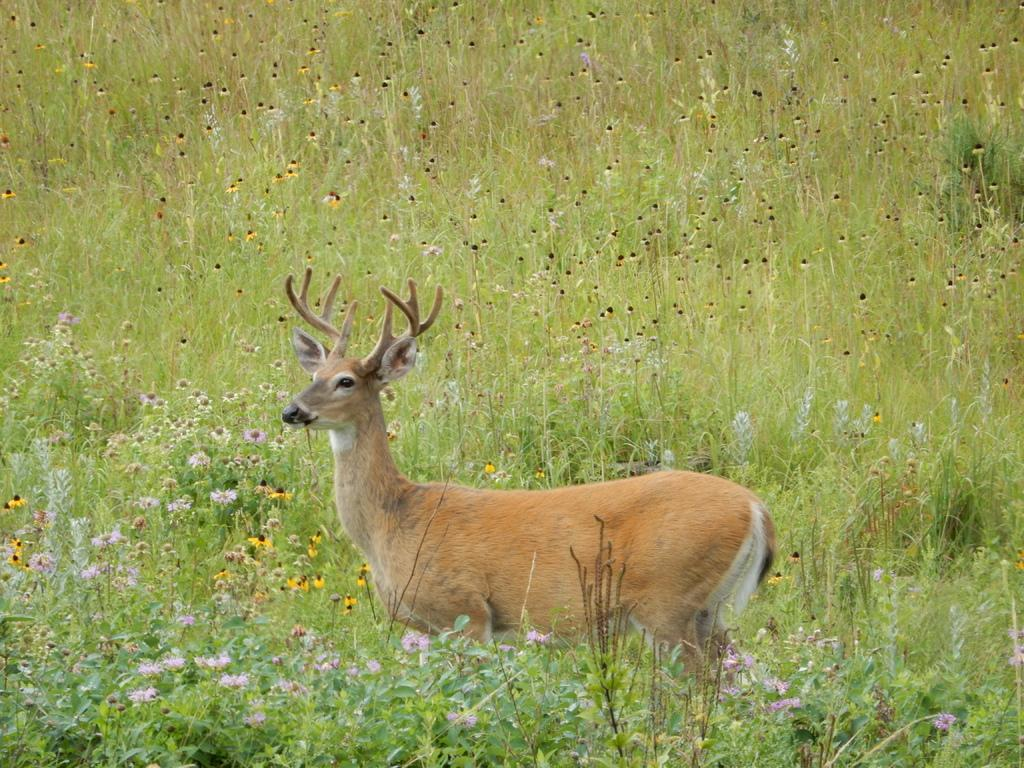What type of vegetation is present in the image? The image contains grass. Are there any other plants visible in the grass? Yes, there are small flowers in the grass. What animal can be seen in the image? There is a deer in the image. What type of destruction can be seen in the image? There is no destruction present in the image; it features grass, small flowers, and a deer. What key is used to unlock the gate in the image? There is no gate or key present in the image. 